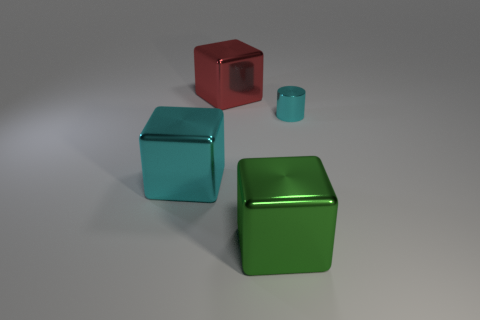Are there any distinguishable textures on the surfaces of the blocks? While the objects in the image reflect light in a manner that suggests they could have a smooth texture, the image resolution limits the ability to discern fine surface details. 